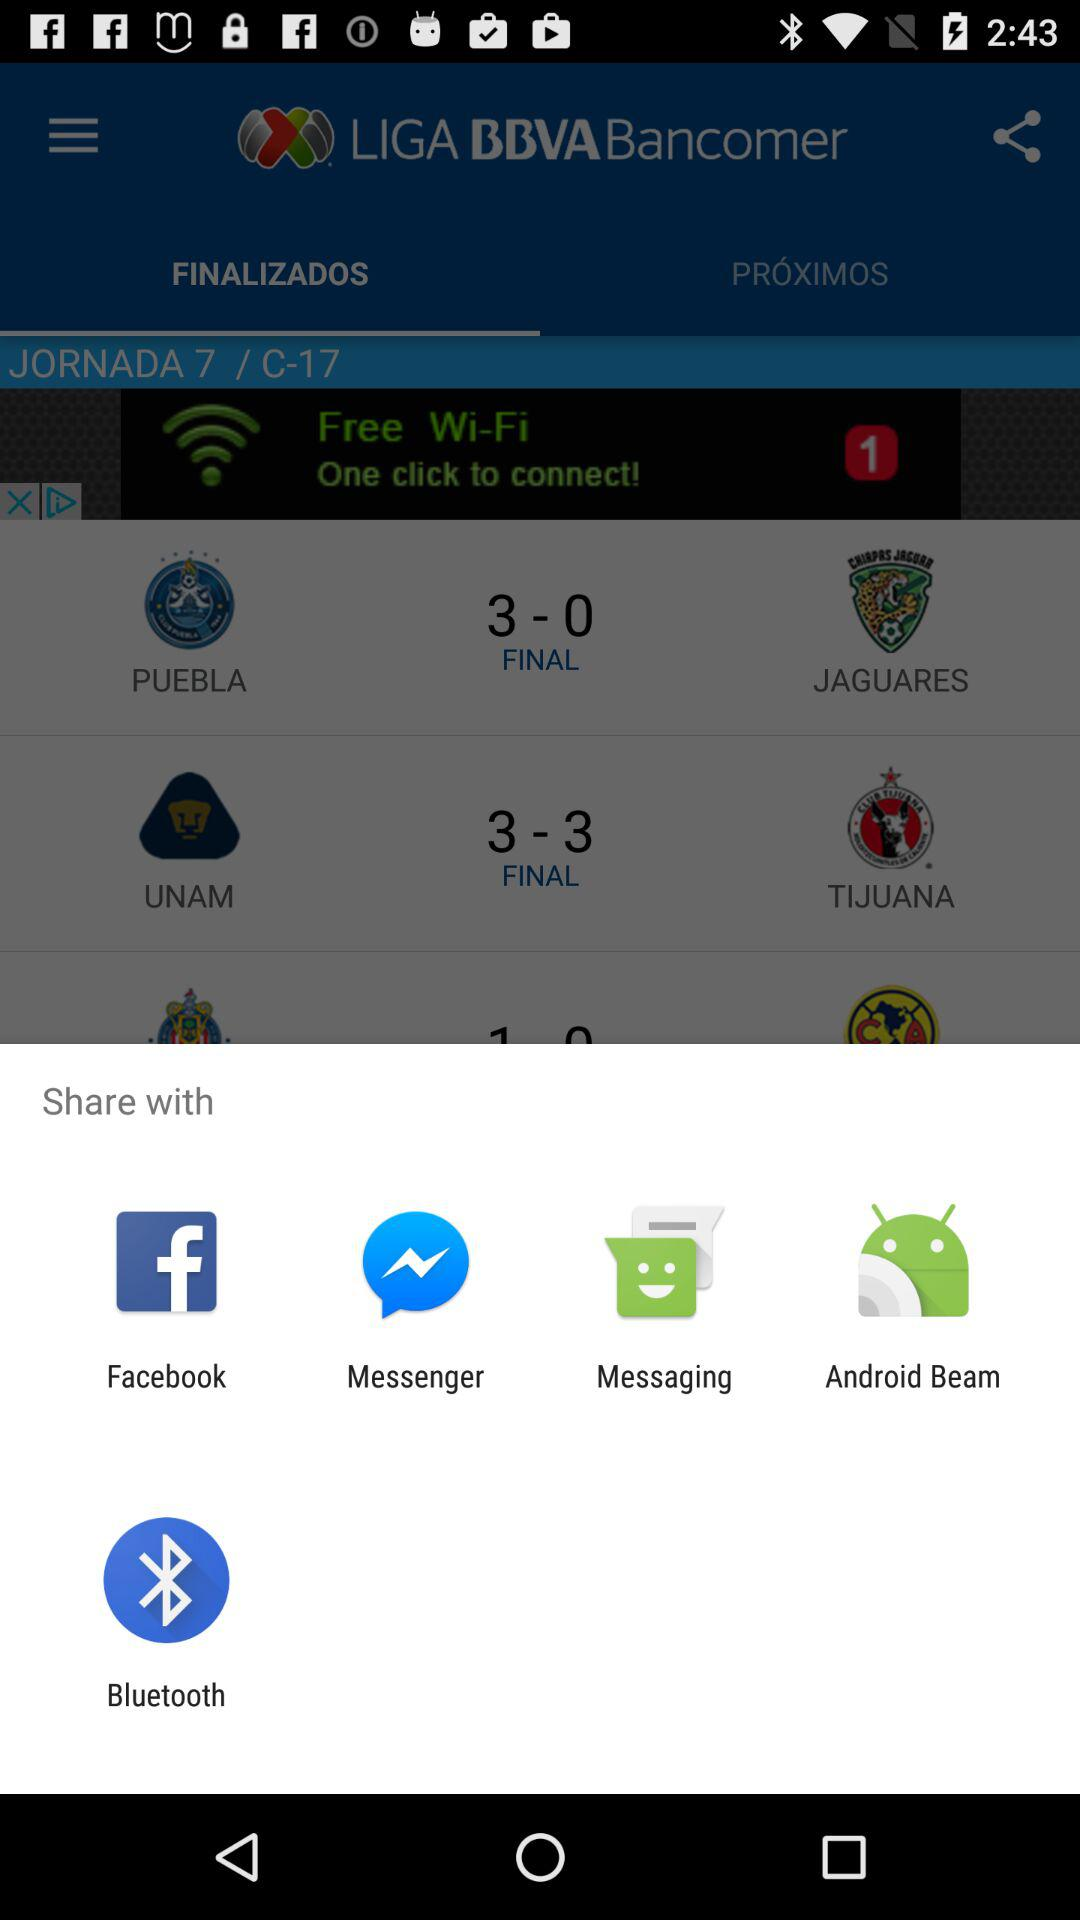Through what applications can we share? You can share it through "Facebook", "Messenger", "Messaging", "Android Beam", and "Bluetooth". 